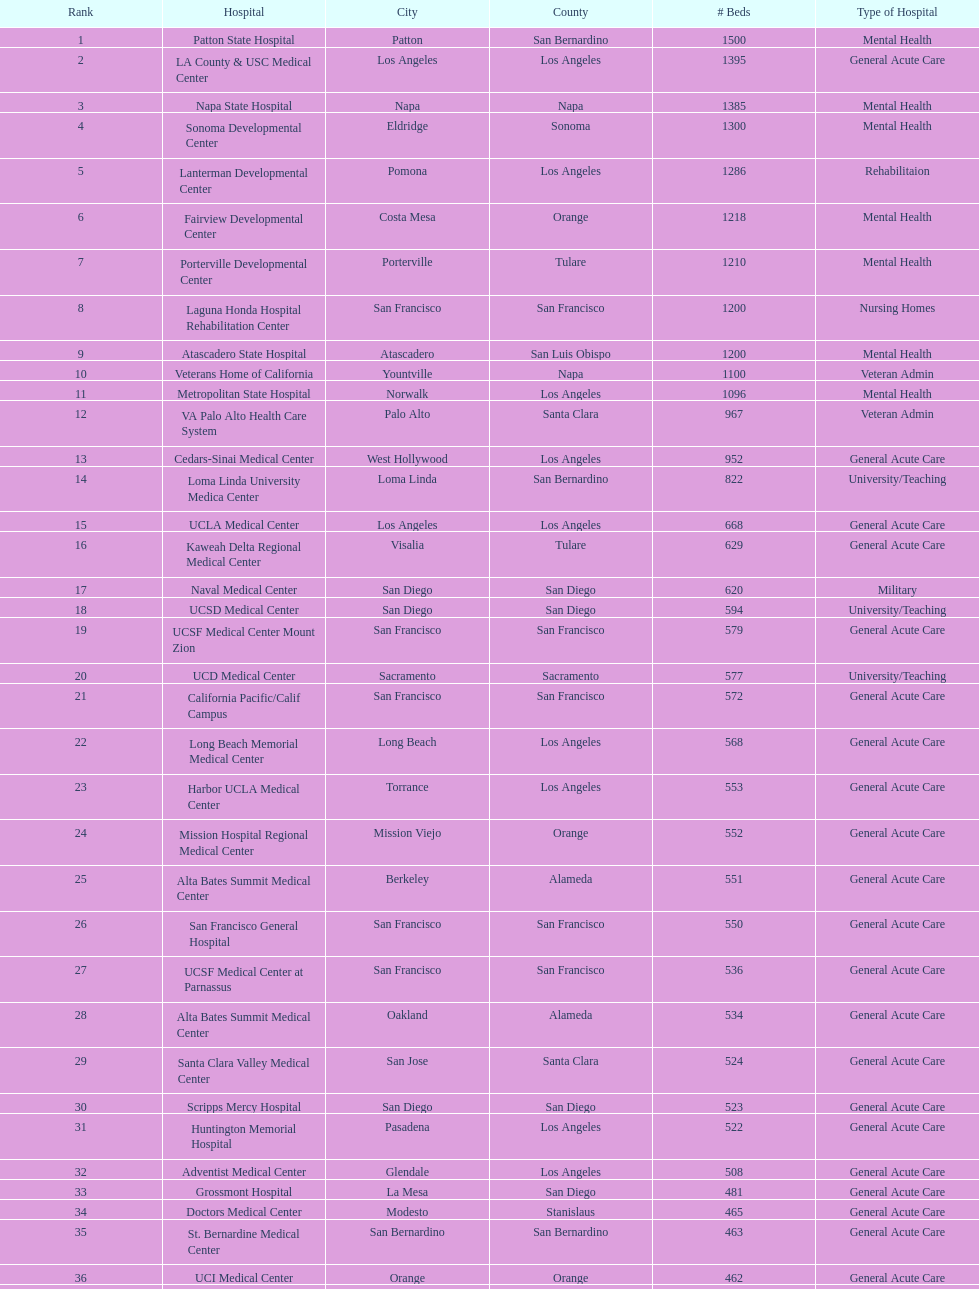In los angeles county, which hospital that provides rehabilitation-focused beds is ranked within the top 10 hospitals? Lanterman Developmental Center. 